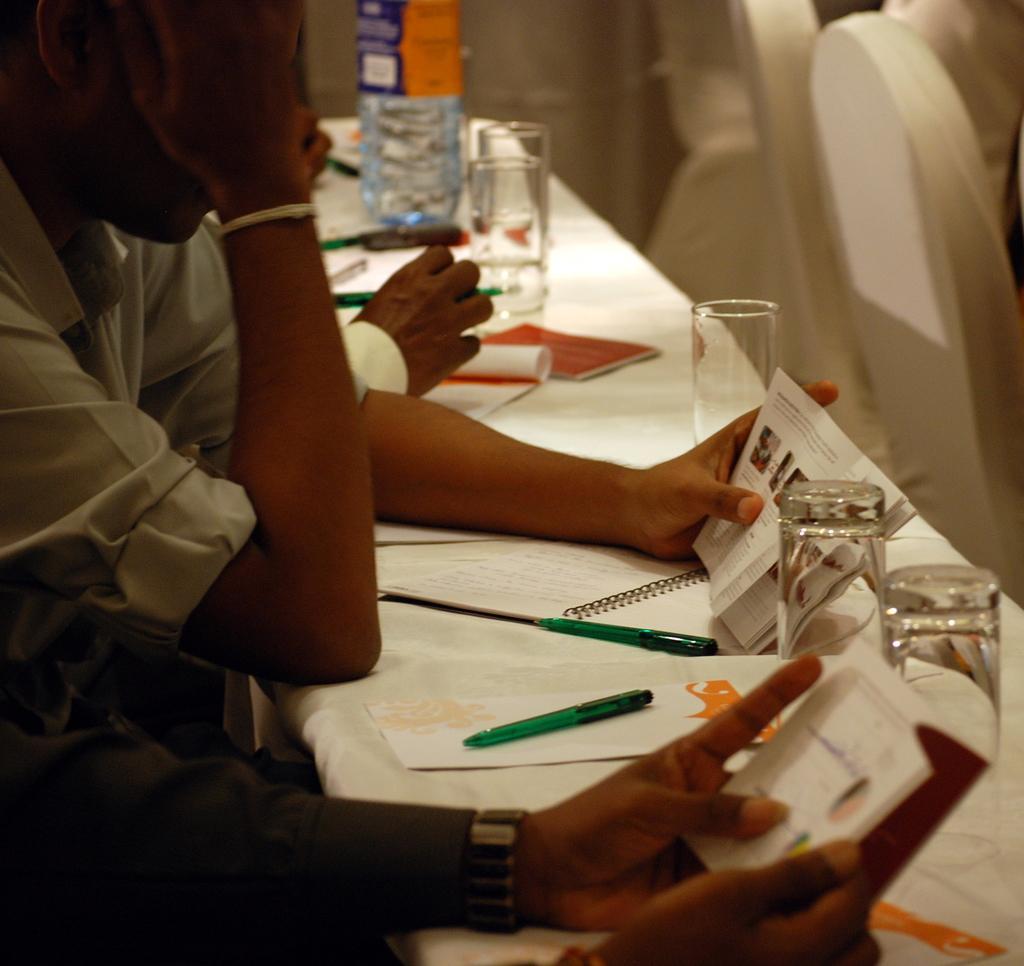In one or two sentences, can you explain what this image depicts? In this image I can see few persons are sitting in front of the white colored desks and on the desks I can see few papers, few pens, few glasses and few other objects. 